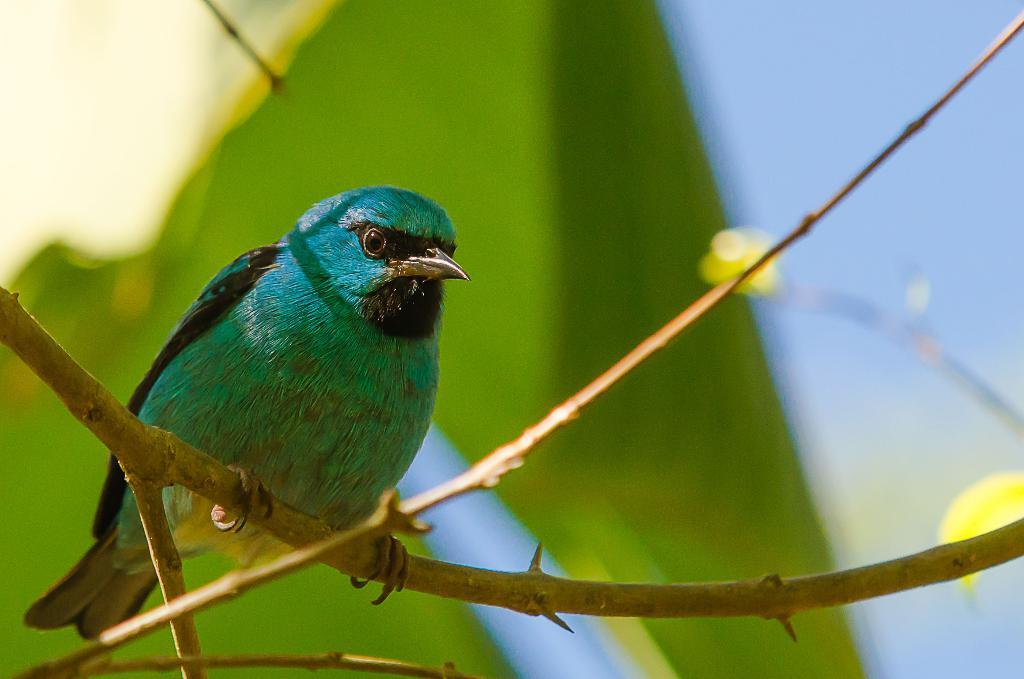What type of animal is in the image? There is a bird in the image. Where is the bird located? The bird is on a branch. Can you describe the background of the image? The background of the image is blurred. What type of drum is the bird playing in the image? There is no drum present in the image; it features a bird on a branch. What type of loss is the bird experiencing in the image? There is no indication of any loss experienced by the bird in the image. 